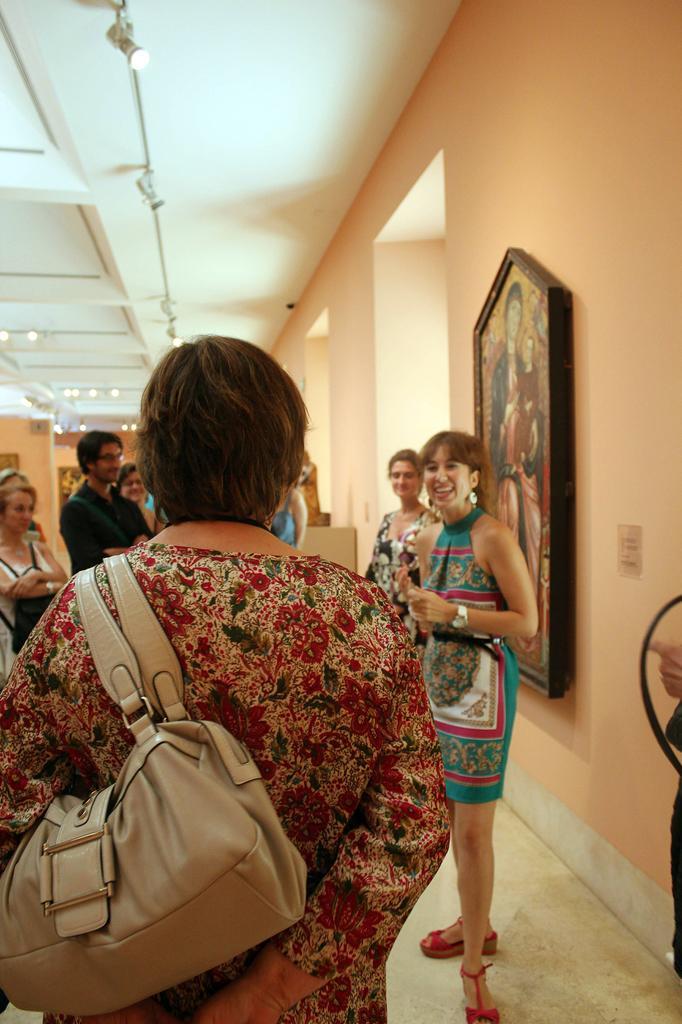Could you give a brief overview of what you see in this image? In this picture there are people, among them there is a person carrying a bag and we can see frame on the wall. At the top of the image we can see lights. 